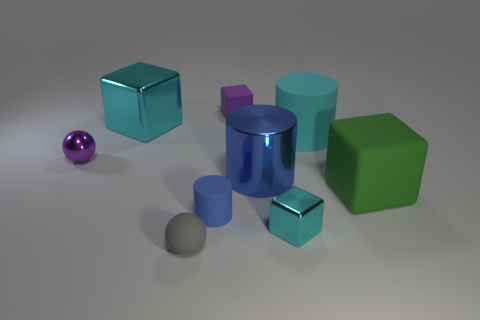Subtract 1 cubes. How many cubes are left? 3 Subtract all cubes. How many objects are left? 5 Add 7 cyan metal blocks. How many cyan metal blocks exist? 9 Subtract 0 brown balls. How many objects are left? 9 Subtract all gray rubber objects. Subtract all small matte objects. How many objects are left? 5 Add 5 matte balls. How many matte balls are left? 6 